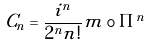Convert formula to latex. <formula><loc_0><loc_0><loc_500><loc_500>C _ { n } = \frac { i ^ { n } } { 2 ^ { n } n ! } m \circ \Pi ^ { n }</formula> 